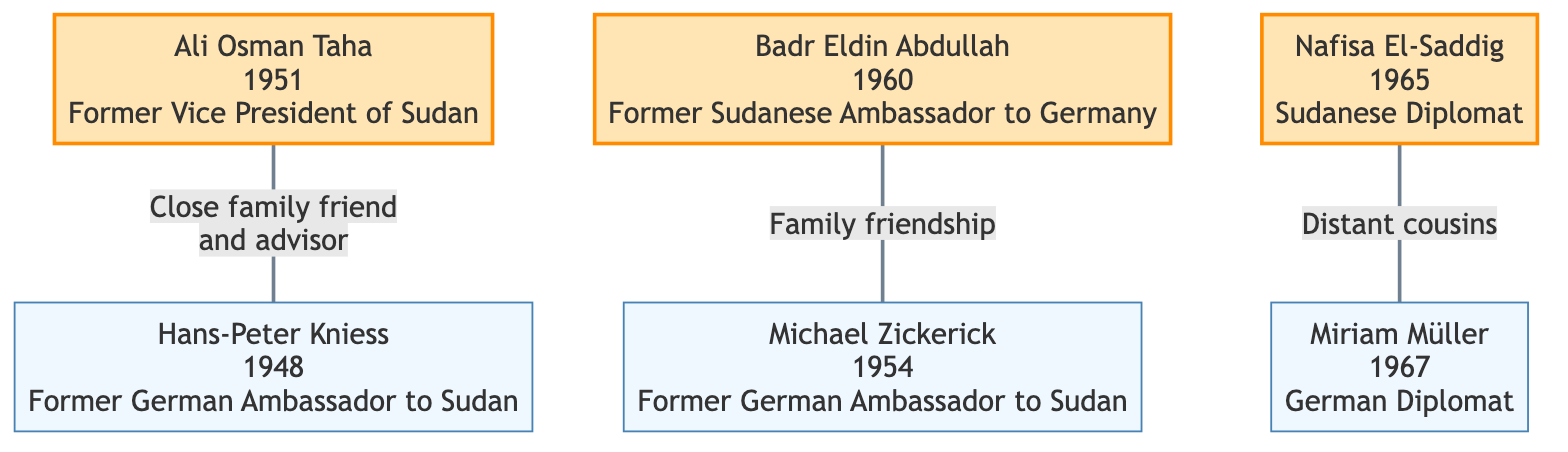What is the name of the former Sudanese Vice President? The diagram identifies Ali Osman Taha as the former Vice President of Sudan, indicated by the label next to his node.
Answer: Ali Osman Taha Who was a close family friend and advisor to Ali Osman Taha? The relationship line connecting Ali Osman Taha to Hans-Peter Kniess specifies that Hans-Peter Kniess was a close family friend and advisor.
Answer: Hans-Peter Kniess How many Sudanese officials are represented in the diagram? By counting the Sudanese nodes, there are three: Ali Osman Taha, Badr Eldin Abdullah, and Nafisa El-Saddig.
Answer: 3 What relationship exists between Badr Eldin Abdullah and Michael Zickerick? The relationship line indicates a family friendship initiated during their respective terms as ambassadors, connecting the two officials.
Answer: Family friendship Who are the distant cousins in the diagram? The relationship between Nafisa El-Saddig and Miriam Müller is specified as distant cousins, showing a familial link between them.
Answer: Nafisa El-Saddig and Miriam Müller What year was Hans-Peter Kniess born? The diagram shows that Hans-Peter Kniess was born in 1948, as indicated in the information beside his node.
Answer: 1948 Which two officials share a relationship based on their ambassadorial terms? The relationship between Badr Eldin Abdullah and Michael Zickerick is based on a family friendship during their ambassadorial terms.
Answer: Badr Eldin Abdullah and Michael Zickerick How many total officials are depicted in the diagram? Counting all the nodes, there are six officials shown in the diagram: three Sudanese and three Germans.
Answer: 6 What position did Nafisa El-Saddig hold? The node for Nafisa El-Saddig specifies that she is a Sudanese diplomat, giving her professional title.
Answer: Sudanese Diplomat 